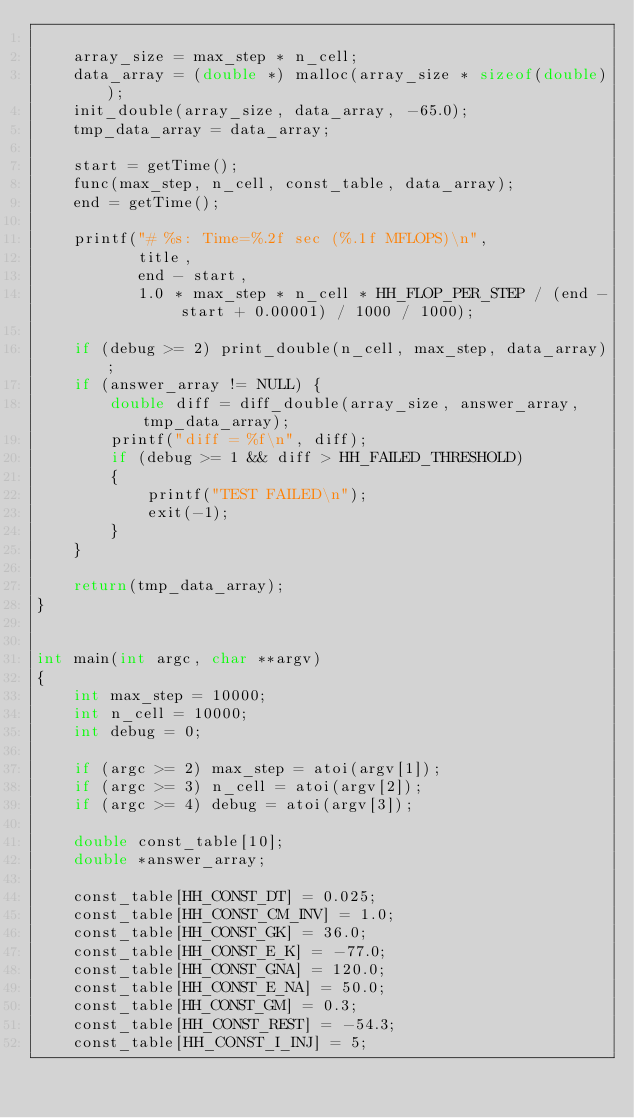<code> <loc_0><loc_0><loc_500><loc_500><_C_>
    array_size = max_step * n_cell;
    data_array = (double *) malloc(array_size * sizeof(double));
    init_double(array_size, data_array, -65.0);
    tmp_data_array = data_array;

    start = getTime();
    func(max_step, n_cell, const_table, data_array);
    end = getTime();

    printf("# %s: Time=%.2f sec (%.1f MFLOPS)\n",
           title,
           end - start,
           1.0 * max_step * n_cell * HH_FLOP_PER_STEP / (end - start + 0.00001) / 1000 / 1000);

    if (debug >= 2) print_double(n_cell, max_step, data_array);
    if (answer_array != NULL) {
        double diff = diff_double(array_size, answer_array, tmp_data_array);
        printf("diff = %f\n", diff);
        if (debug >= 1 && diff > HH_FAILED_THRESHOLD)
        {
            printf("TEST FAILED\n");
            exit(-1);
        }
    }

    return(tmp_data_array);
}


int main(int argc, char **argv)
{
    int max_step = 10000;
    int n_cell = 10000;
    int debug = 0;

    if (argc >= 2) max_step = atoi(argv[1]);
    if (argc >= 3) n_cell = atoi(argv[2]);
    if (argc >= 4) debug = atoi(argv[3]);

    double const_table[10];
    double *answer_array;

    const_table[HH_CONST_DT] = 0.025;
    const_table[HH_CONST_CM_INV] = 1.0;
    const_table[HH_CONST_GK] = 36.0;
    const_table[HH_CONST_E_K] = -77.0;
    const_table[HH_CONST_GNA] = 120.0;
    const_table[HH_CONST_E_NA] = 50.0;
    const_table[HH_CONST_GM] = 0.3;
    const_table[HH_CONST_REST] = -54.3;
    const_table[HH_CONST_I_INJ] = 5;

</code> 